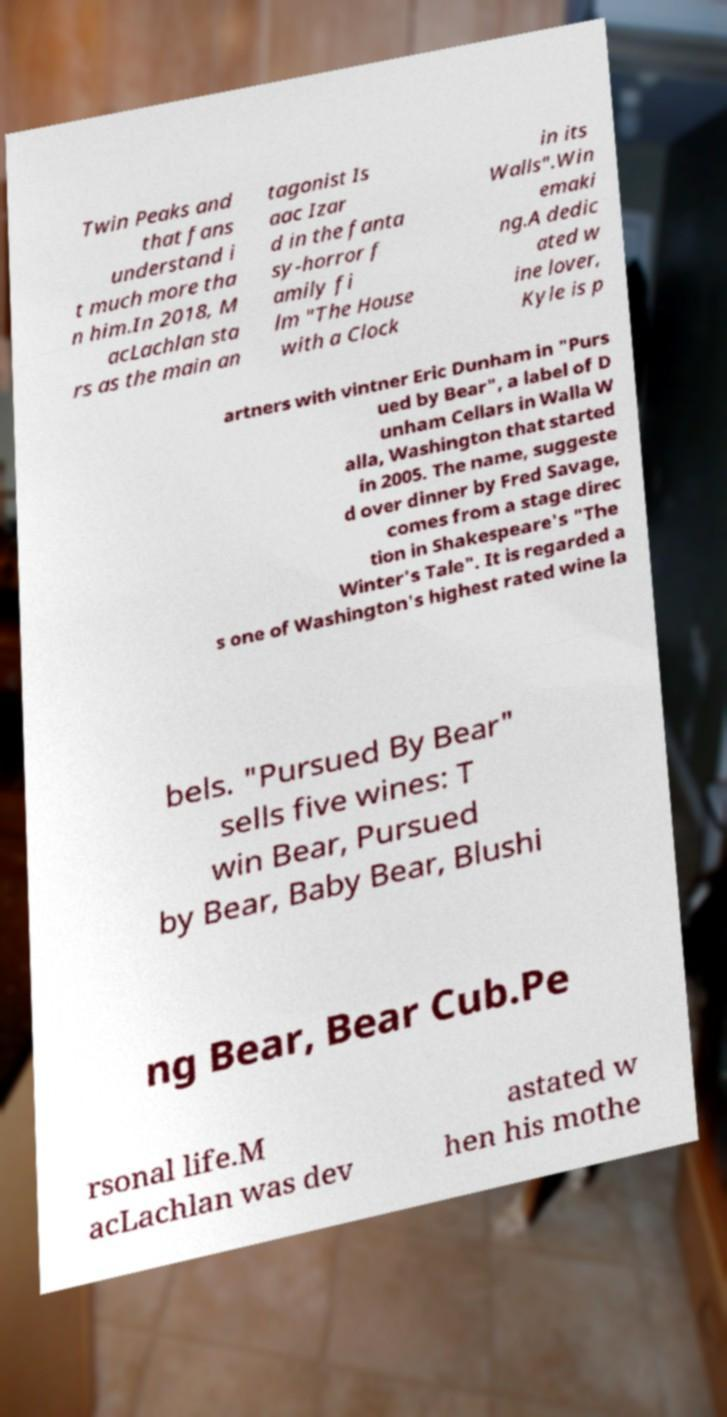Could you assist in decoding the text presented in this image and type it out clearly? Twin Peaks and that fans understand i t much more tha n him.In 2018, M acLachlan sta rs as the main an tagonist Is aac Izar d in the fanta sy-horror f amily fi lm "The House with a Clock in its Walls".Win emaki ng.A dedic ated w ine lover, Kyle is p artners with vintner Eric Dunham in "Purs ued by Bear", a label of D unham Cellars in Walla W alla, Washington that started in 2005. The name, suggeste d over dinner by Fred Savage, comes from a stage direc tion in Shakespeare's "The Winter's Tale". It is regarded a s one of Washington's highest rated wine la bels. "Pursued By Bear" sells five wines: T win Bear, Pursued by Bear, Baby Bear, Blushi ng Bear, Bear Cub.Pe rsonal life.M acLachlan was dev astated w hen his mothe 